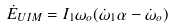Convert formula to latex. <formula><loc_0><loc_0><loc_500><loc_500>\dot { E } _ { U I M } = I _ { 1 } \omega _ { o } ( \dot { \omega } _ { 1 } \alpha - \dot { \omega } _ { o } )</formula> 